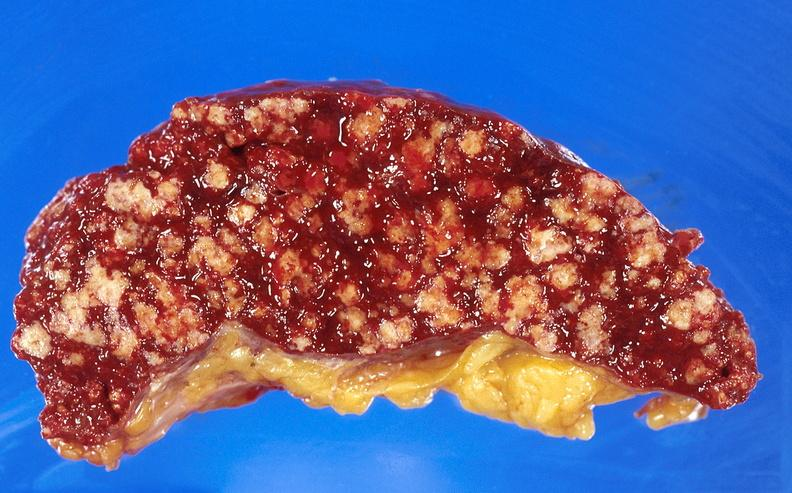what does this image show?
Answer the question using a single word or phrase. Spleen 